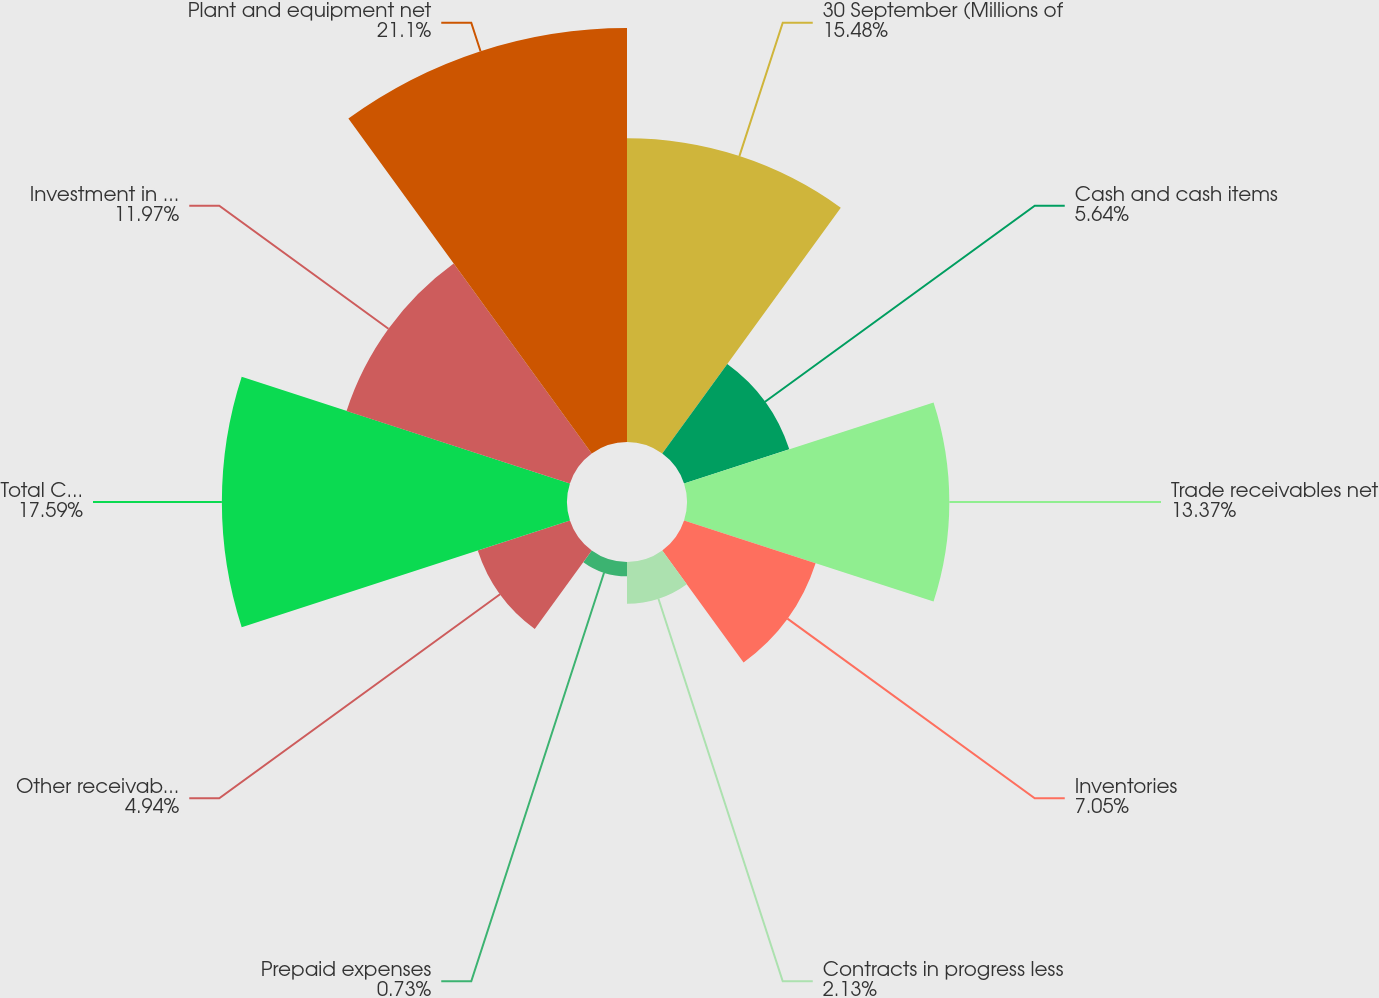<chart> <loc_0><loc_0><loc_500><loc_500><pie_chart><fcel>30 September (Millions of<fcel>Cash and cash items<fcel>Trade receivables net<fcel>Inventories<fcel>Contracts in progress less<fcel>Prepaid expenses<fcel>Other receivables and current<fcel>Total Current Assets<fcel>Investment in net assets of<fcel>Plant and equipment net<nl><fcel>15.48%<fcel>5.64%<fcel>13.37%<fcel>7.05%<fcel>2.13%<fcel>0.73%<fcel>4.94%<fcel>17.59%<fcel>11.97%<fcel>21.1%<nl></chart> 